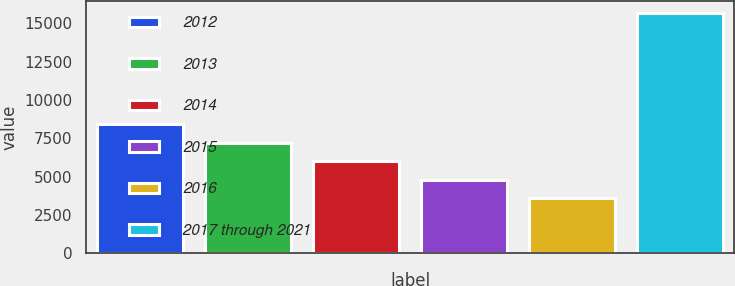Convert chart. <chart><loc_0><loc_0><loc_500><loc_500><bar_chart><fcel>2012<fcel>2013<fcel>2014<fcel>2015<fcel>2016<fcel>2017 through 2021<nl><fcel>8430.4<fcel>7219.8<fcel>6009.2<fcel>4798.6<fcel>3588<fcel>15694<nl></chart> 